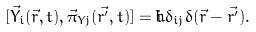Convert formula to latex. <formula><loc_0><loc_0><loc_500><loc_500>[ \vec { Y } _ { i } ( \vec { r } , t ) , \vec { \pi } _ { Y j } ( \vec { r ^ { \prime } } , t ) ] = i \hbar { \delta } _ { i j } \delta ( \vec { r } - \vec { r ^ { \prime } } ) .</formula> 